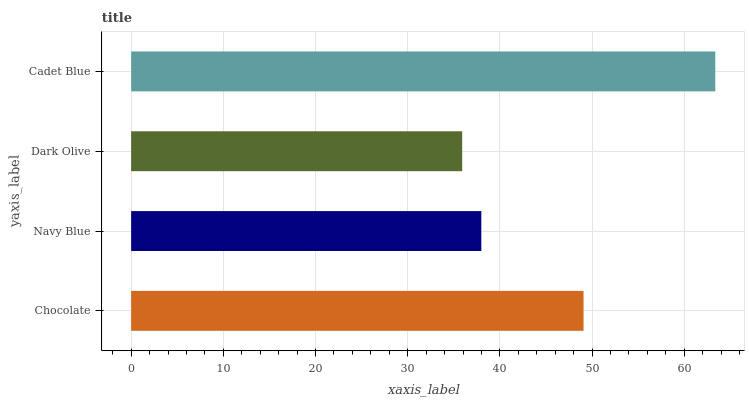Is Dark Olive the minimum?
Answer yes or no. Yes. Is Cadet Blue the maximum?
Answer yes or no. Yes. Is Navy Blue the minimum?
Answer yes or no. No. Is Navy Blue the maximum?
Answer yes or no. No. Is Chocolate greater than Navy Blue?
Answer yes or no. Yes. Is Navy Blue less than Chocolate?
Answer yes or no. Yes. Is Navy Blue greater than Chocolate?
Answer yes or no. No. Is Chocolate less than Navy Blue?
Answer yes or no. No. Is Chocolate the high median?
Answer yes or no. Yes. Is Navy Blue the low median?
Answer yes or no. Yes. Is Dark Olive the high median?
Answer yes or no. No. Is Dark Olive the low median?
Answer yes or no. No. 